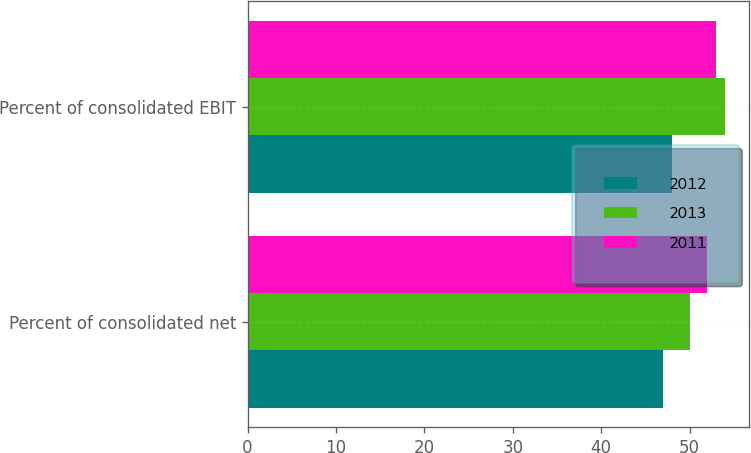Convert chart to OTSL. <chart><loc_0><loc_0><loc_500><loc_500><stacked_bar_chart><ecel><fcel>Percent of consolidated net<fcel>Percent of consolidated EBIT<nl><fcel>2012<fcel>47<fcel>48<nl><fcel>2013<fcel>50<fcel>54<nl><fcel>2011<fcel>52<fcel>53<nl></chart> 